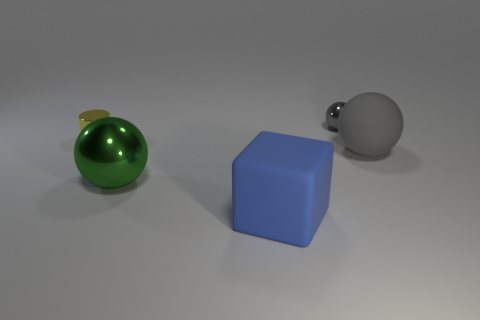Add 3 blue matte objects. How many objects exist? 8 Subtract all cylinders. How many objects are left? 4 Subtract 0 brown cylinders. How many objects are left? 5 Subtract all green things. Subtract all tiny gray spheres. How many objects are left? 3 Add 5 small yellow cylinders. How many small yellow cylinders are left? 6 Add 1 tiny cyan shiny balls. How many tiny cyan shiny balls exist? 1 